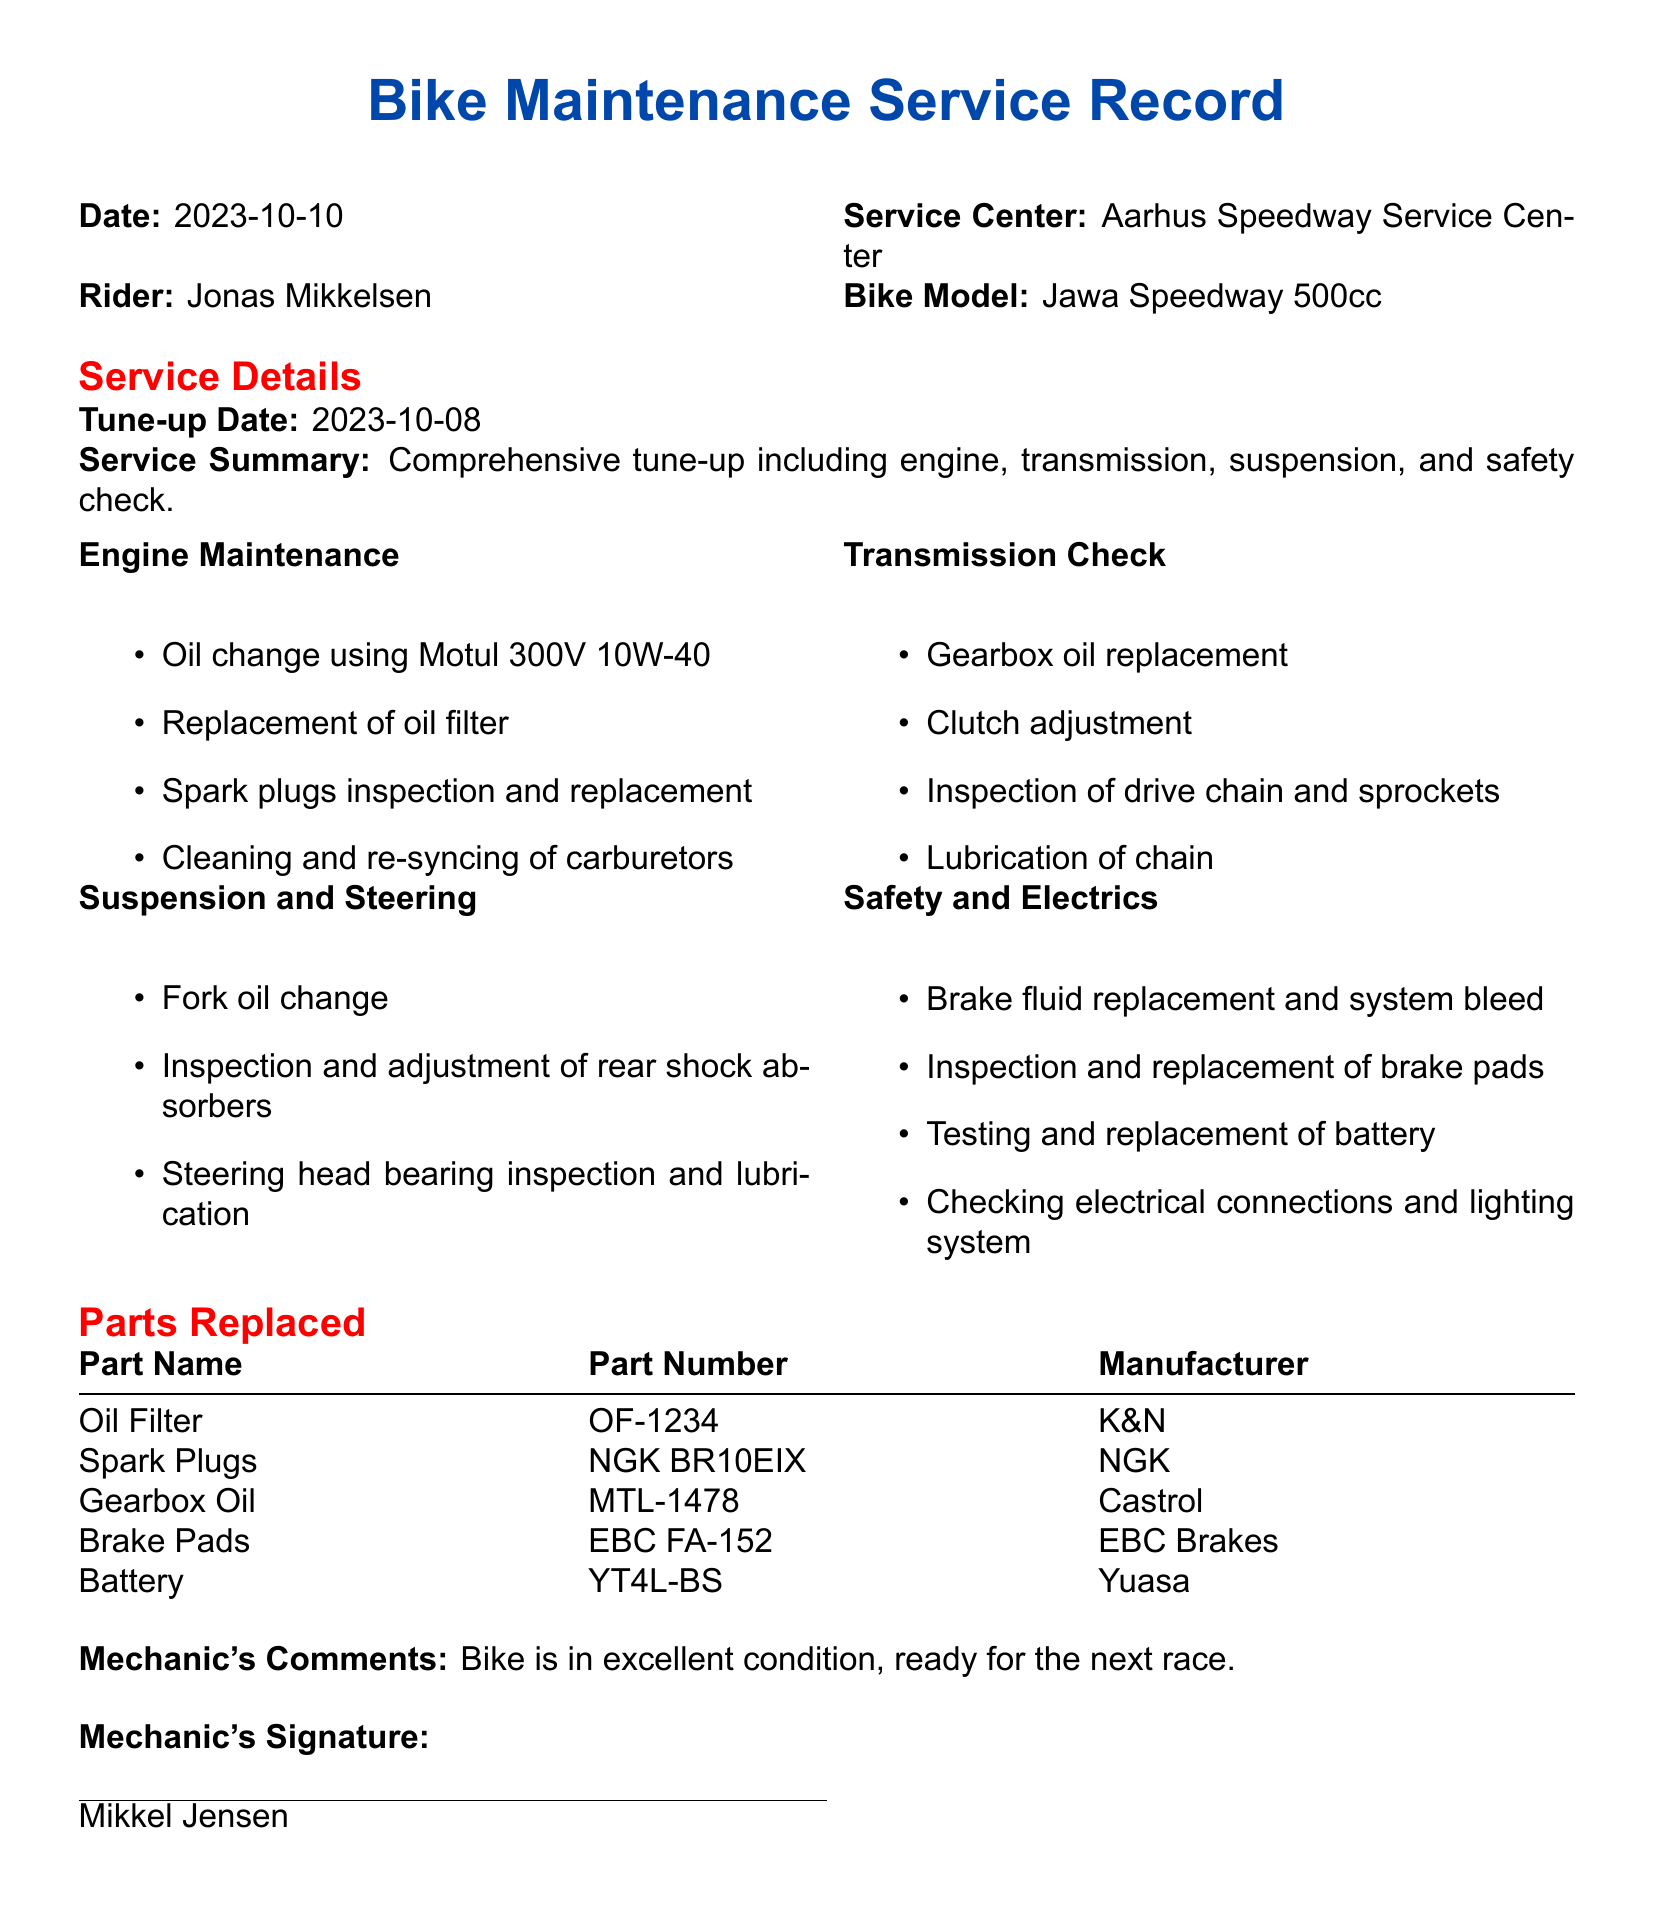what is the date of the latest tune-up? The date of the latest tune-up is listed in the service details section of the document.
Answer: 2023-10-08 who performed the maintenance service? The mechanic who performed the maintenance service is mentioned at the end of the document.
Answer: Mikkel Jensen what type of oil was used for the engine change? The specific oil used for the engine change is listed in the engine maintenance section.
Answer: Motul 300V 10W-40 how many parts were replaced during the service? The number of parts replaced can be counted from the parts replaced section of the document.
Answer: 5 what is the name of the rider? The name of the rider is provided in the introductory section of the document.
Answer: Jonas Mikkelsen which company manufactured the battery? The manufacturer of the battery is specified in the parts replaced section of the document.
Answer: Yuasa what was replaced in the transmission check? Items replaced in the transmission check can be found in the transmission check section of the document.
Answer: Gearbox oil what is the inspection performed on the steering? The specific inspection carried out on the steering is detailed in the suspension and steering section.
Answer: Steering head bearing inspection and lubrication what was the mechanic's comment on the bike's condition? The mechanic's comment regarding the bike's condition is stated at the end of the document.
Answer: Bike is in excellent condition, ready for the next race 